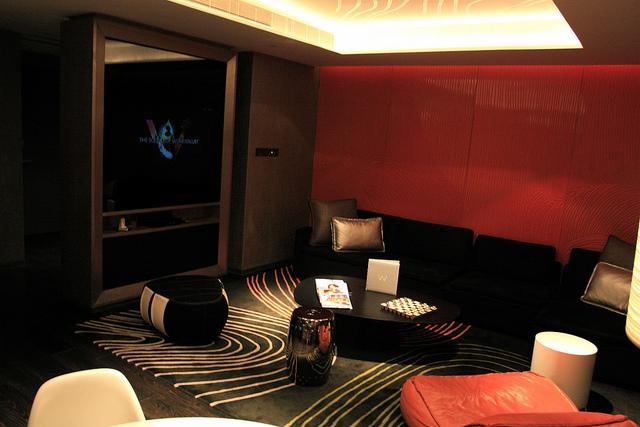What is on the floor?
Write a very short answer. Rug. What type of room is this?
Give a very brief answer. Living room. Is this a cheap room?
Quick response, please. No. 